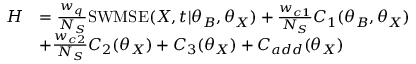<formula> <loc_0><loc_0><loc_500><loc_500>\begin{array} { r l } { H } & { = \frac { w _ { q } } { N _ { S } } S W M S E ( X , t | \theta _ { B } , \theta _ { X } ) + \frac { w _ { c 1 } } { N _ { S } } C _ { 1 } ( \theta _ { B } , \theta _ { X } ) } \\ & { + \frac { w _ { c 2 } } { N _ { S } } C _ { 2 } ( \theta _ { X } ) + C _ { 3 } ( \theta _ { X } ) + C _ { a d d } ( \theta _ { X } ) } \end{array}</formula> 